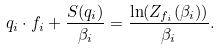Convert formula to latex. <formula><loc_0><loc_0><loc_500><loc_500>q _ { i } \cdot f _ { i } + \frac { S ( q _ { i } ) } { \beta _ { i } } = \frac { { \ln ( Z _ { f _ { i } } ( \beta _ { i } ) ) } } { \beta _ { i } } .</formula> 